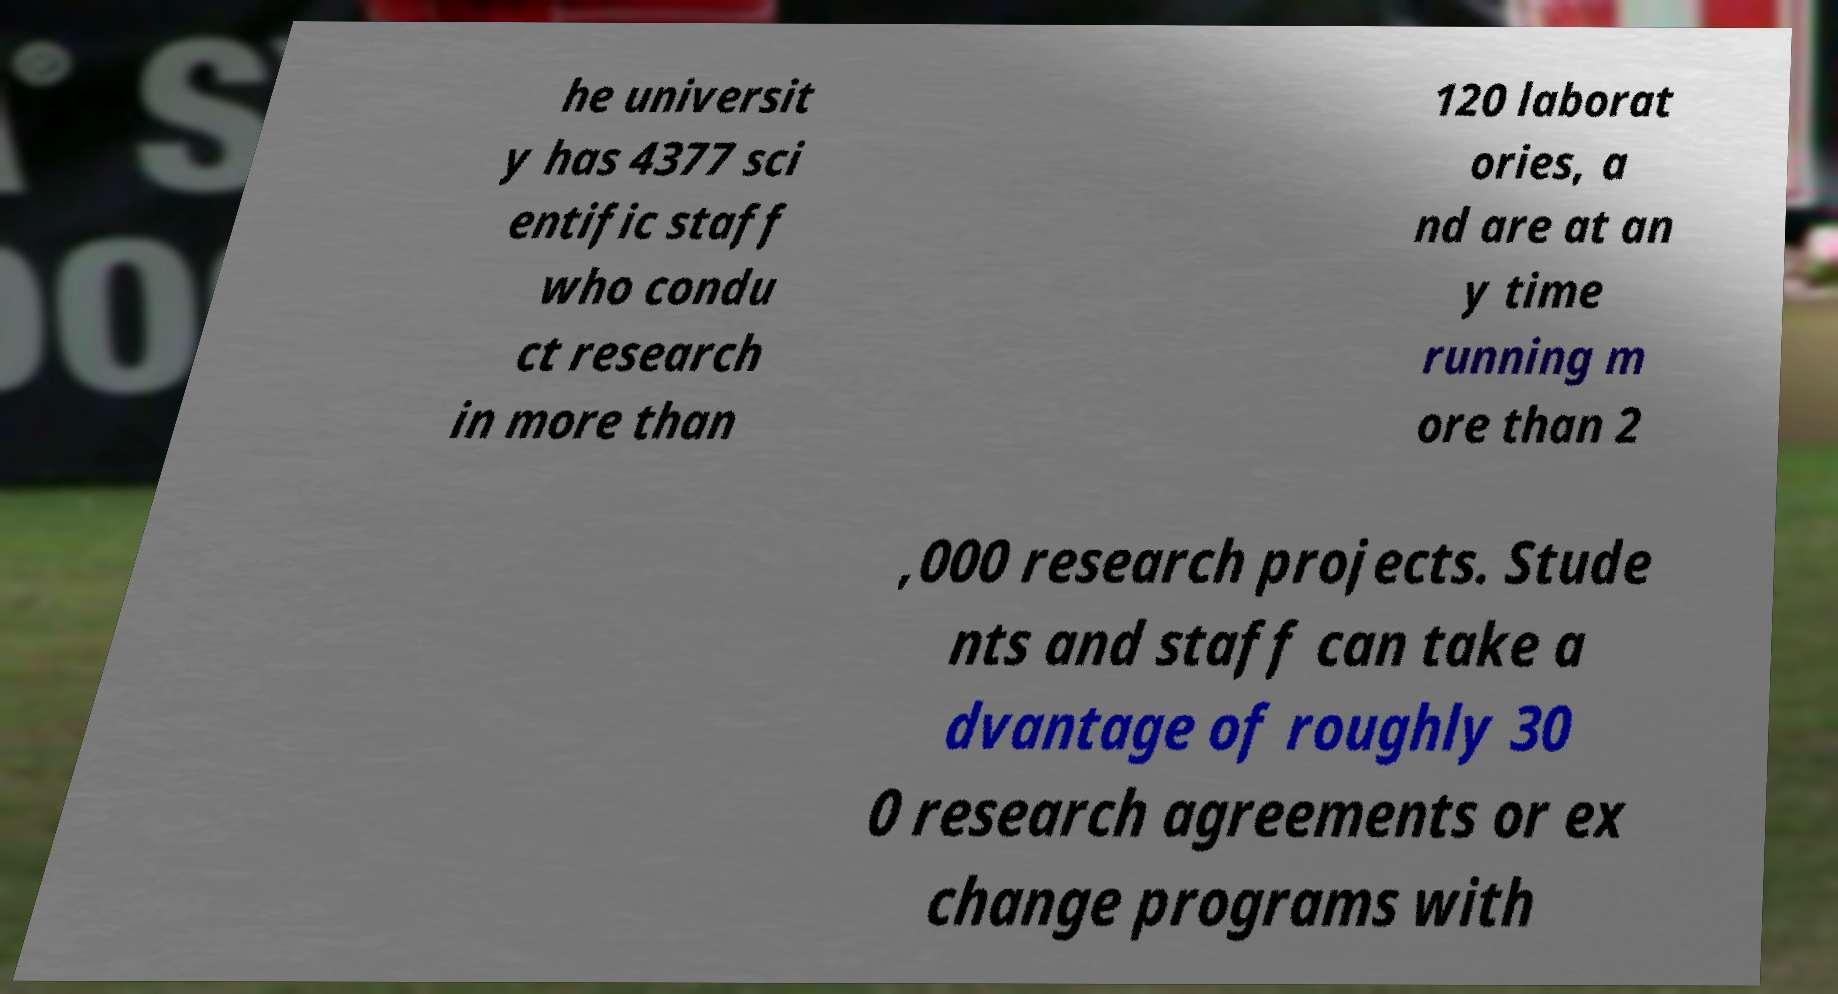Please read and relay the text visible in this image. What does it say? he universit y has 4377 sci entific staff who condu ct research in more than 120 laborat ories, a nd are at an y time running m ore than 2 ,000 research projects. Stude nts and staff can take a dvantage of roughly 30 0 research agreements or ex change programs with 